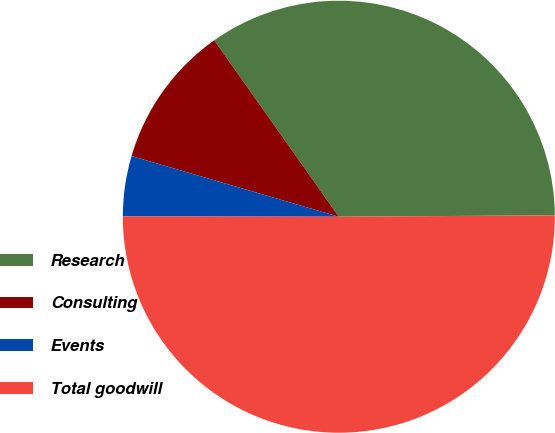Convert chart. <chart><loc_0><loc_0><loc_500><loc_500><pie_chart><fcel>Research<fcel>Consulting<fcel>Events<fcel>Total goodwill<nl><fcel>34.68%<fcel>10.68%<fcel>4.51%<fcel>50.13%<nl></chart> 